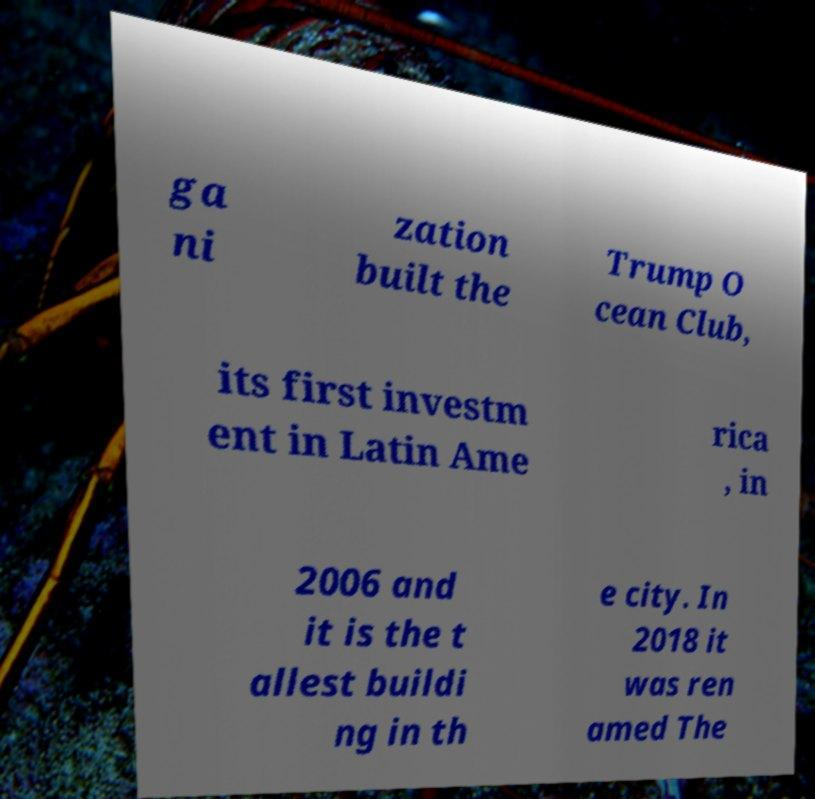Could you extract and type out the text from this image? ga ni zation built the Trump O cean Club, its first investm ent in Latin Ame rica , in 2006 and it is the t allest buildi ng in th e city. In 2018 it was ren amed The 